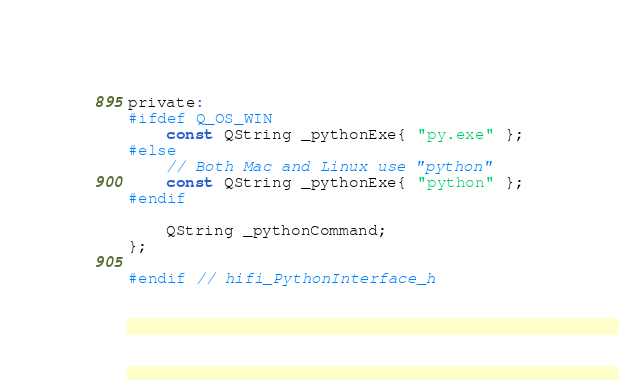Convert code to text. <code><loc_0><loc_0><loc_500><loc_500><_C_>
private:
#ifdef Q_OS_WIN
    const QString _pythonExe{ "py.exe" };
#else
    // Both Mac and Linux use "python"
    const QString _pythonExe{ "python" };
#endif

    QString _pythonCommand;
};

#endif // hifi_PythonInterface_h</code> 